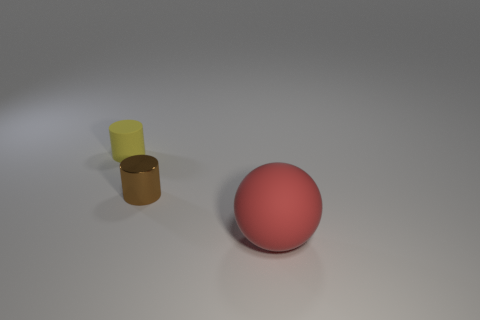Add 1 large rubber things. How many objects exist? 4 Subtract all balls. How many objects are left? 2 Subtract 1 brown cylinders. How many objects are left? 2 Subtract all brown cylinders. Subtract all red balls. How many cylinders are left? 1 Subtract all small brown metallic things. Subtract all tiny brown metal things. How many objects are left? 1 Add 1 small brown metal cylinders. How many small brown metal cylinders are left? 2 Add 1 purple cylinders. How many purple cylinders exist? 1 